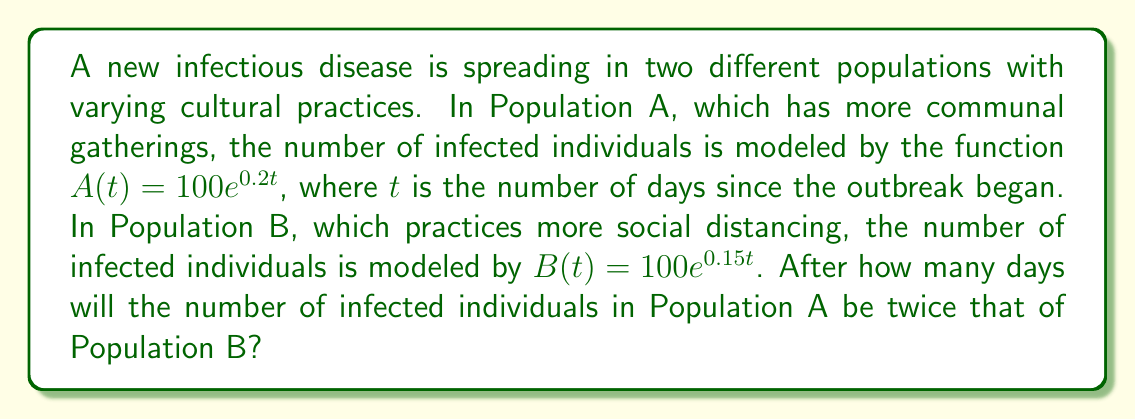Can you solve this math problem? To solve this problem, we need to follow these steps:

1) We want to find $t$ when $A(t) = 2B(t)$

2) Let's set up the equation:
   $100e^{0.2t} = 2(100e^{0.15t})$

3) Simplify the right side:
   $100e^{0.2t} = 200e^{0.15t}$

4) Divide both sides by 100:
   $e^{0.2t} = 2e^{0.15t}$

5) Take the natural log of both sides:
   $\ln(e^{0.2t}) = \ln(2e^{0.15t})$

6) Simplify using log properties:
   $0.2t = \ln(2) + 0.15t$

7) Subtract 0.15t from both sides:
   $0.05t = \ln(2)$

8) Divide both sides by 0.05:
   $t = \frac{\ln(2)}{0.05}$

9) Calculate the final answer:
   $t \approx 13.86$

Since we're dealing with days, we round up to the nearest whole number.
Answer: 14 days 